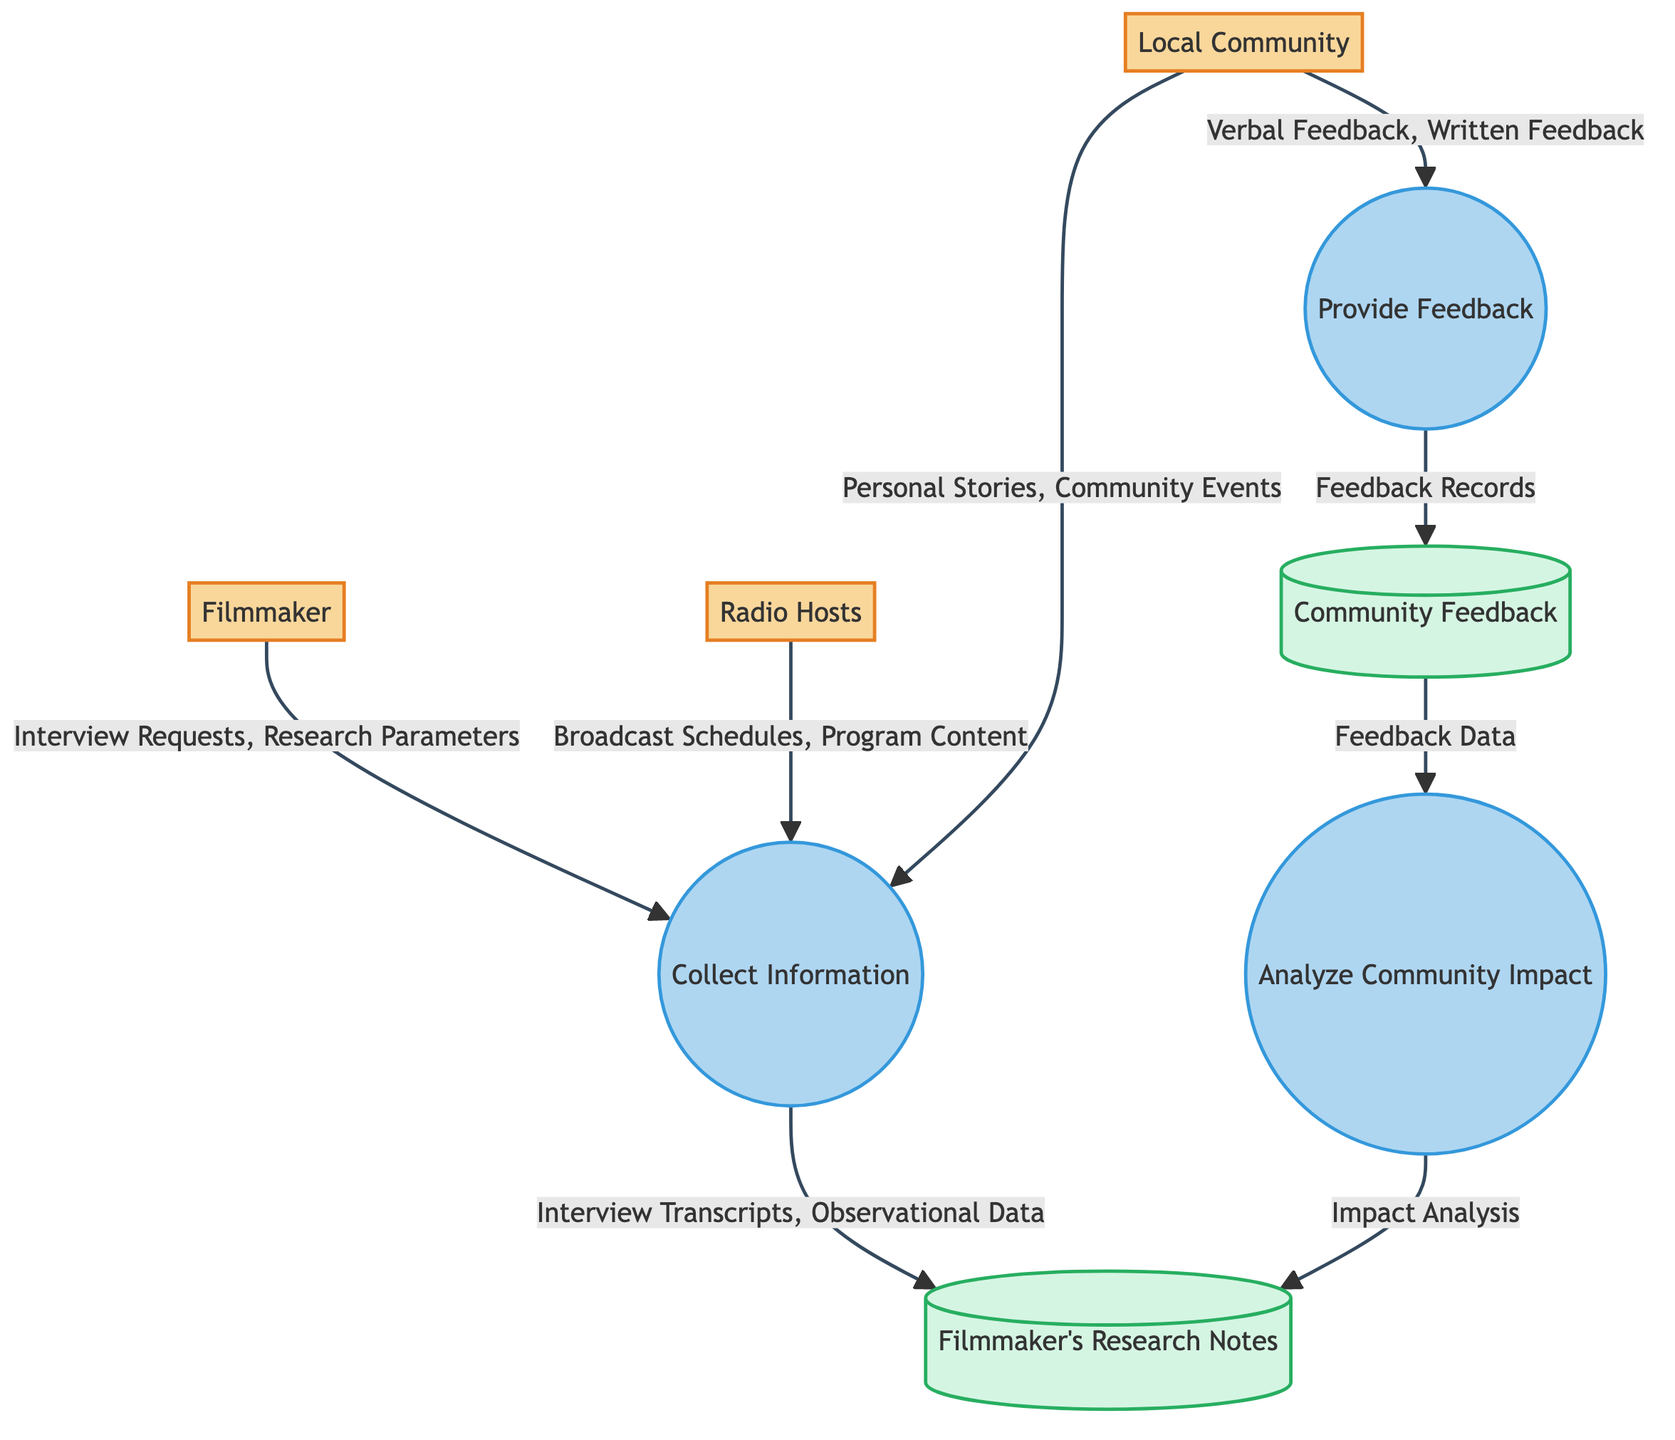What are the incoming data sources to the "Collect Information" process? The incoming data sources to the "Collect Information" process are the Filmmaker, Radio Hosts, and Local Community. Each of these entities provides specific input data to this process.
Answer: Filmmaker, Radio Hosts, Local Community How many external entities are represented in the diagram? The diagram displays three external entities: Filmmaker, Radio Hosts, and Local Community. By counting these entities, we find that there are three in total.
Answer: 3 What type of data does the Local Community provide to the "Collect Information" process? The Local Community provides Personal Stories and Community Events as data to the "Collect Information" process. This type of data reflects the community's direct experiences and interactions with radio broadcasts.
Answer: Personal Stories, Community Events Which process is responsible for turning the Community Feedback into Filmmaker's Research Notes? The process responsible for this transformation is "Analyze Community Impact." It takes the Community Feedback as input and generates Impact Analysis, which then updates the Filmmaker's Research Notes.
Answer: Analyze Community Impact What is the outgoing data from the "Provide Feedback" process? The outgoing data from the "Provide Feedback" process is Feedback Records. This data represents the collected feedback from the Local Community after they provide their comments to the Filmmaker and Radio Hosts.
Answer: Feedback Records How does the Filmmaker gather information from Radio Hosts? The Filmmaker gathers information from Radio Hosts by receiving data such as Broadcast Schedules and Program Content, which are directed to the "Collect Information" process. This flow of data enables the filmmaker to contextualize radio programming within the documentary.
Answer: Broadcast Schedules, Program Content What data flow follows the "Community Feedback" data store? Following the "Community Feedback" data store, the data flow goes to the "Analyze Community Impact" process. This flow indicates that the analysis of feedback is crucial to understanding the overall impact of radio broadcasts on the local community.
Answer: Analyze Community Impact What type of feedback does the Local Community give in the "Provide Feedback" process? The Local Community provides Verbal Feedback and Written Feedback in the "Provide Feedback" process. Both types of feedback serve as valuable insights into the community's response to radio broadcasts.
Answer: Verbal Feedback, Written Feedback 